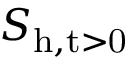Convert formula to latex. <formula><loc_0><loc_0><loc_500><loc_500>S _ { h , t > 0 }</formula> 